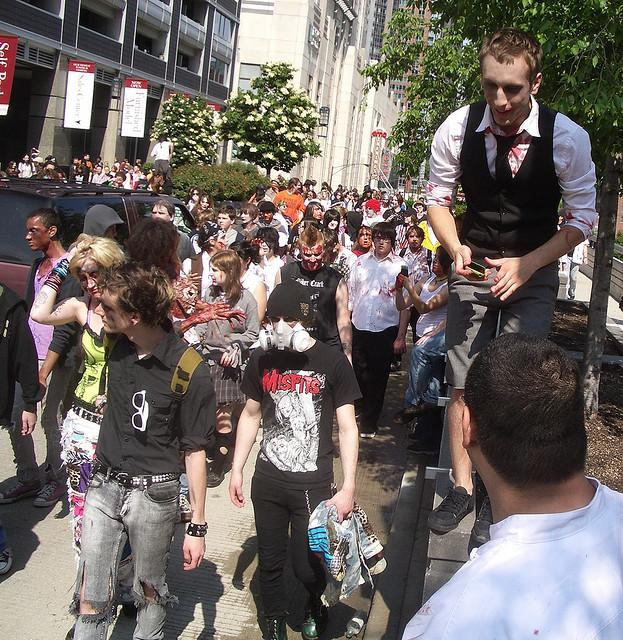The band on the shirt of the man wearing a mask belongs to what genre of music?

Choices:
A) punk
B) country
C) hip hop
D) blues punk 